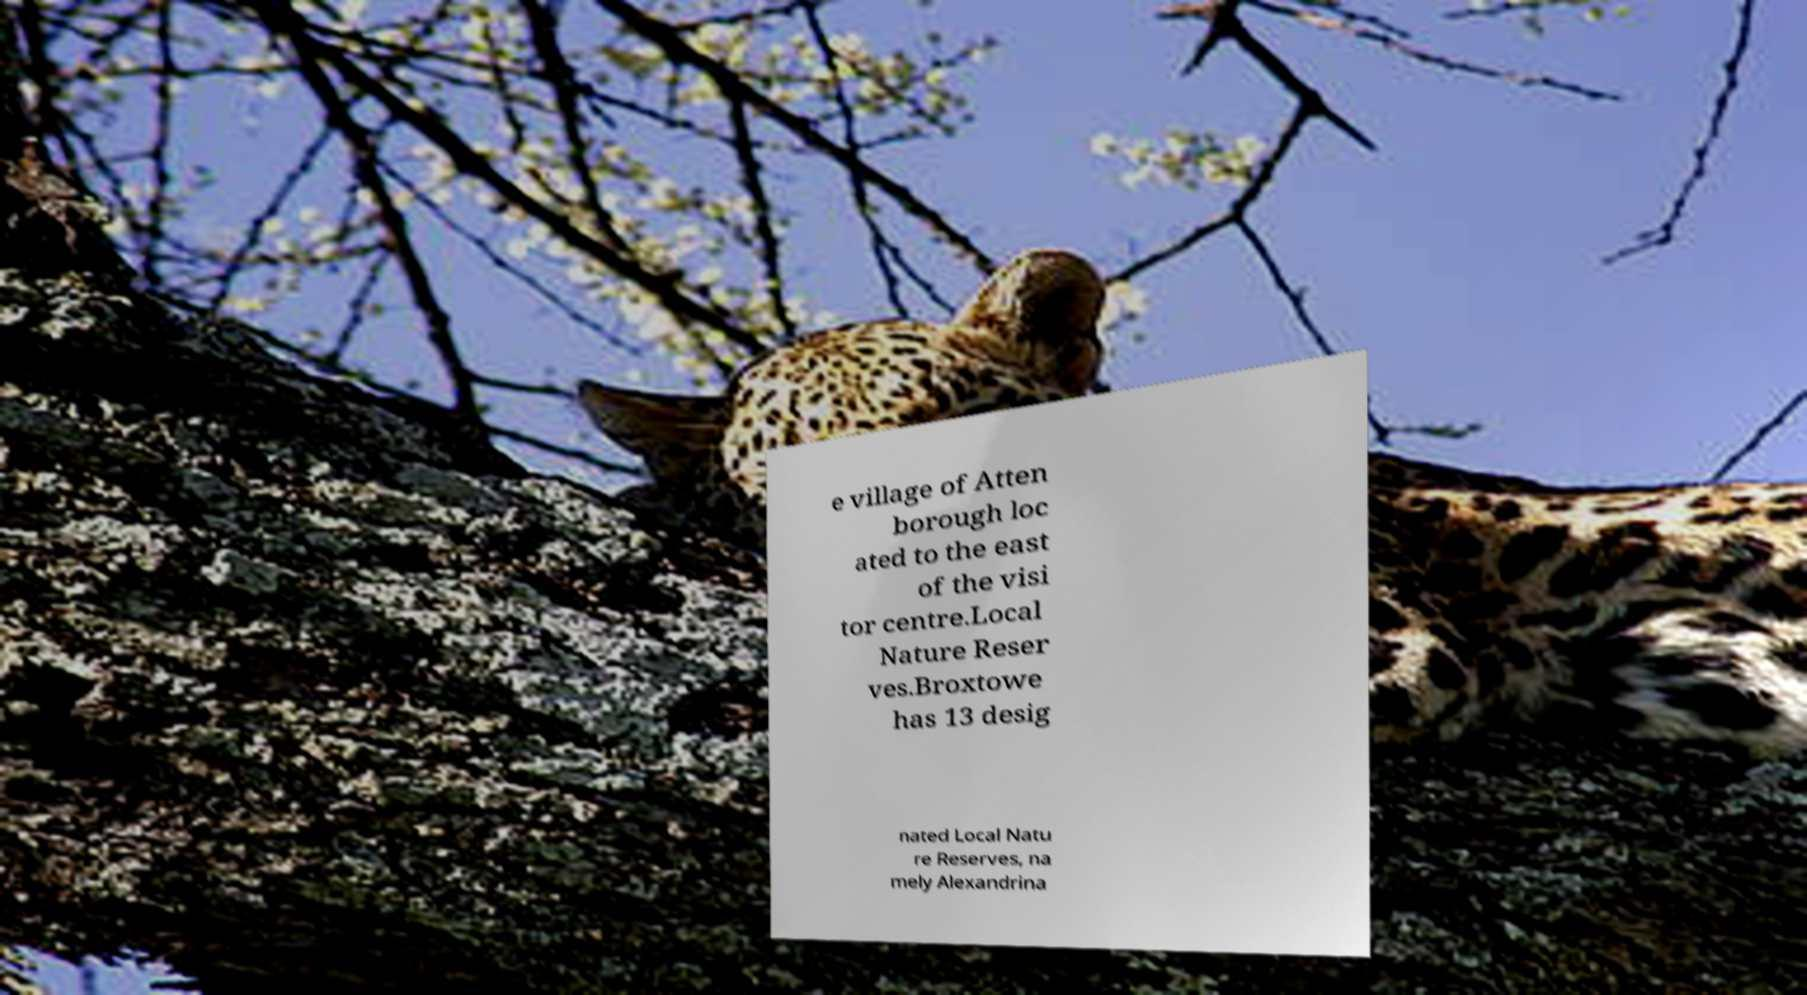Could you extract and type out the text from this image? e village of Atten borough loc ated to the east of the visi tor centre.Local Nature Reser ves.Broxtowe has 13 desig nated Local Natu re Reserves, na mely Alexandrina 